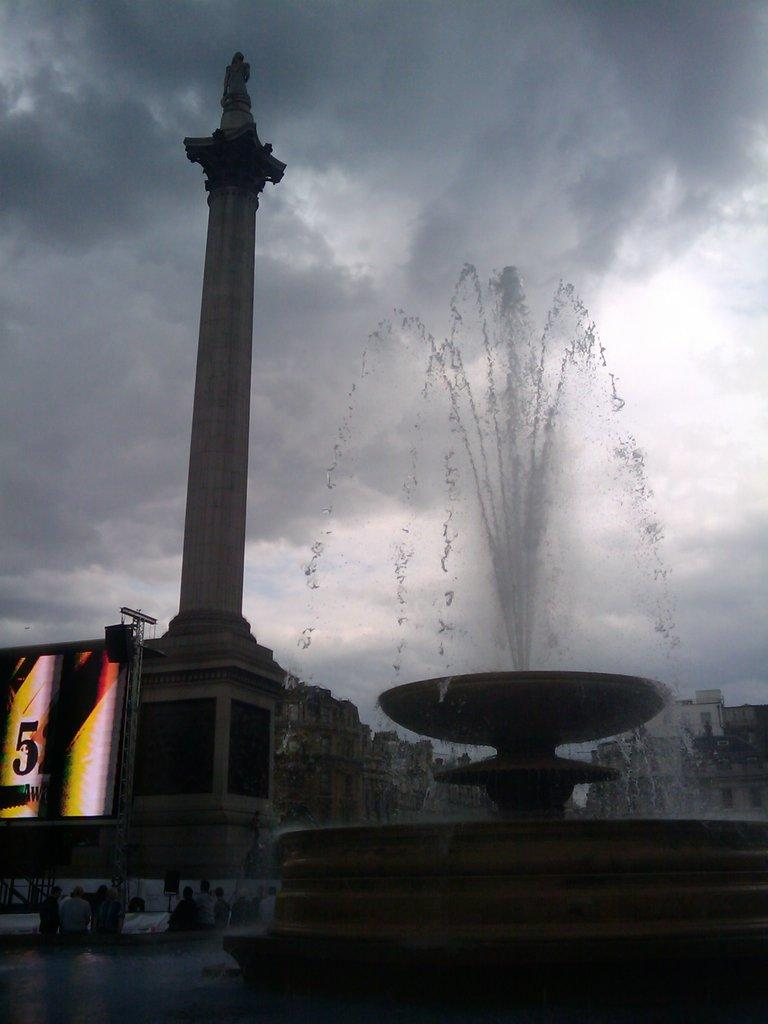<image>
Summarize the visual content of the image. A water fountain is spewing water into the air and a cloudy overcast sky is above a sign that says 51. 